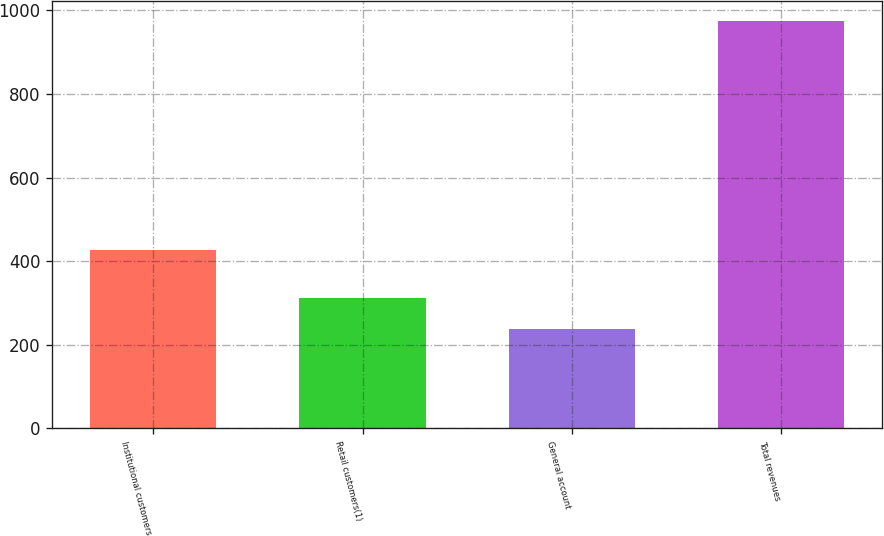Convert chart. <chart><loc_0><loc_0><loc_500><loc_500><bar_chart><fcel>Institutional customers<fcel>Retail customers(1)<fcel>General account<fcel>Total revenues<nl><fcel>426<fcel>311.6<fcel>238<fcel>974<nl></chart> 